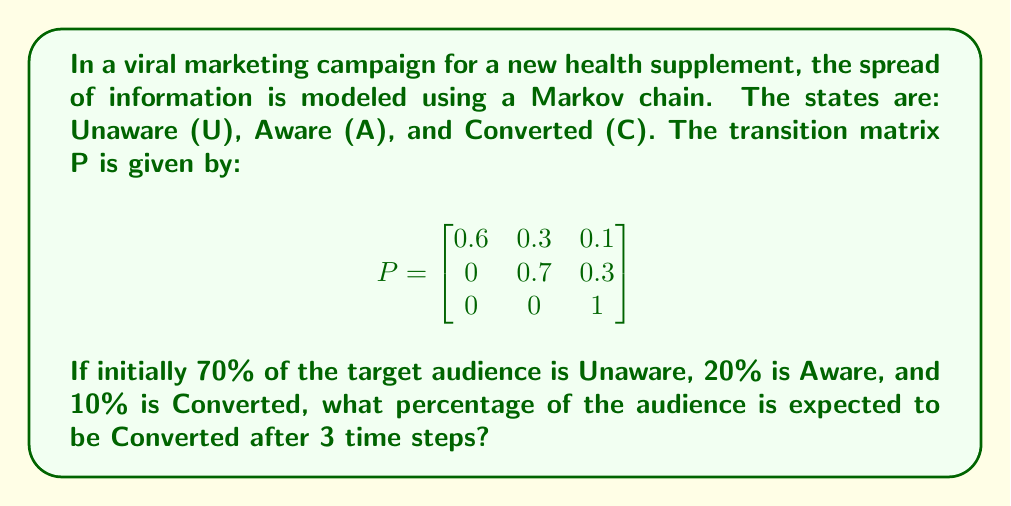Show me your answer to this math problem. Let's approach this step-by-step:

1) First, we need to represent the initial state as a row vector:
   $\pi_0 = [0.7 \quad 0.2 \quad 0.1]$

2) To find the state after 3 time steps, we need to multiply this initial state by the transition matrix P raised to the power of 3:
   $\pi_3 = \pi_0 \cdot P^3$

3) Let's calculate $P^3$:
   $P^2 = P \cdot P = \begin{bmatrix}
   0.36 & 0.39 & 0.25 \\
   0 & 0.49 & 0.51 \\
   0 & 0 & 1
   \end{bmatrix}$

   $P^3 = P^2 \cdot P = \begin{bmatrix}
   0.216 & 0.363 & 0.421 \\
   0 & 0.343 & 0.657 \\
   0 & 0 & 1
   \end{bmatrix}$

4) Now we can multiply $\pi_0$ by $P^3$:
   $\pi_3 = [0.7 \quad 0.2 \quad 0.1] \cdot \begin{bmatrix}
   0.216 & 0.363 & 0.421 \\
   0 & 0.343 & 0.657 \\
   0 & 0 & 1
   \end{bmatrix}$

5) Performing the matrix multiplication:
   $\pi_3 = [0.1512 \quad 0.3221 \quad 0.5267]$

6) The last element of this vector represents the proportion of Converted individuals after 3 time steps.

7) To convert to a percentage, we multiply by 100:
   $0.5267 \times 100 = 52.67\%$
Answer: 52.67% 